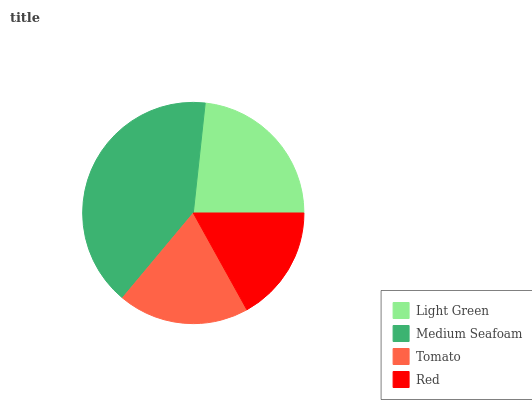Is Red the minimum?
Answer yes or no. Yes. Is Medium Seafoam the maximum?
Answer yes or no. Yes. Is Tomato the minimum?
Answer yes or no. No. Is Tomato the maximum?
Answer yes or no. No. Is Medium Seafoam greater than Tomato?
Answer yes or no. Yes. Is Tomato less than Medium Seafoam?
Answer yes or no. Yes. Is Tomato greater than Medium Seafoam?
Answer yes or no. No. Is Medium Seafoam less than Tomato?
Answer yes or no. No. Is Light Green the high median?
Answer yes or no. Yes. Is Tomato the low median?
Answer yes or no. Yes. Is Tomato the high median?
Answer yes or no. No. Is Light Green the low median?
Answer yes or no. No. 